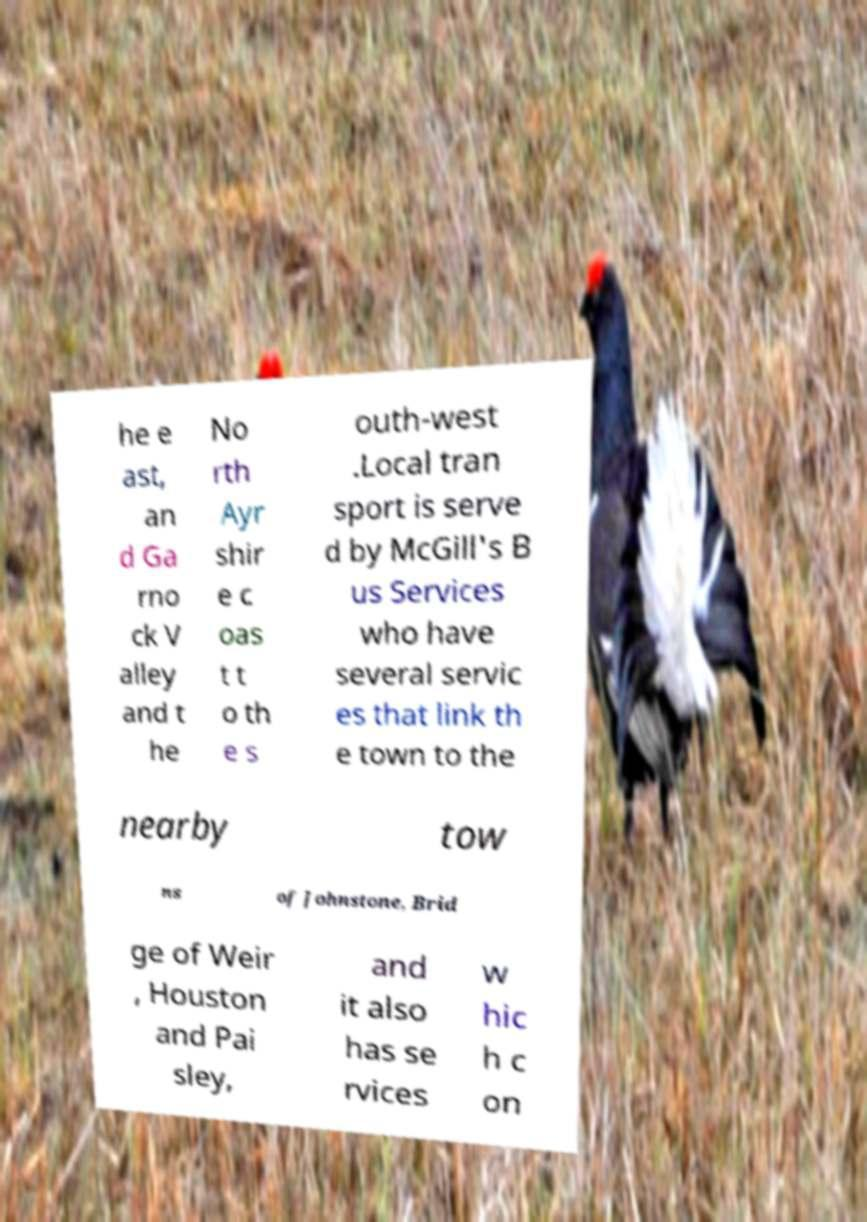Could you extract and type out the text from this image? he e ast, an d Ga rno ck V alley and t he No rth Ayr shir e c oas t t o th e s outh-west .Local tran sport is serve d by McGill's B us Services who have several servic es that link th e town to the nearby tow ns of Johnstone, Brid ge of Weir , Houston and Pai sley, and it also has se rvices w hic h c on 